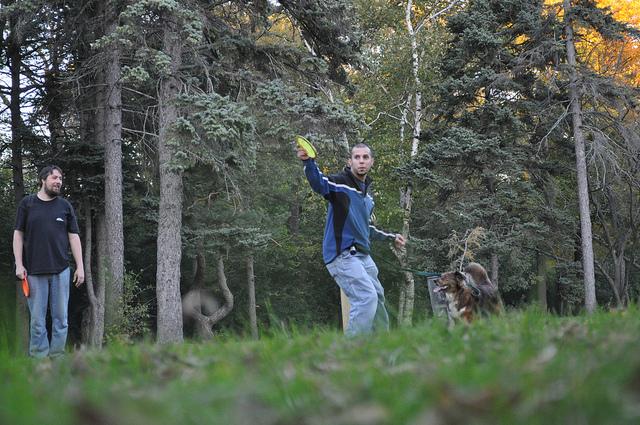What is the man throwing?
Be succinct. Frisbee. How many people are wearing black?
Answer briefly. 1. Is this man brushing his teeth?
Write a very short answer. No. Is the Frisbee right side-up or upside-down?
Write a very short answer. Right side-up. Has the gray tree, upper left, lost limbs?
Answer briefly. Yes. Is this person wearing safety equipment?
Give a very brief answer. No. What kind of orchid are the boys in?
Keep it brief. Forest. What color is the Frisbee the man waiting  holding?
Concise answer only. Yellow. What sport are they playing?
Short answer required. Frisbee. 